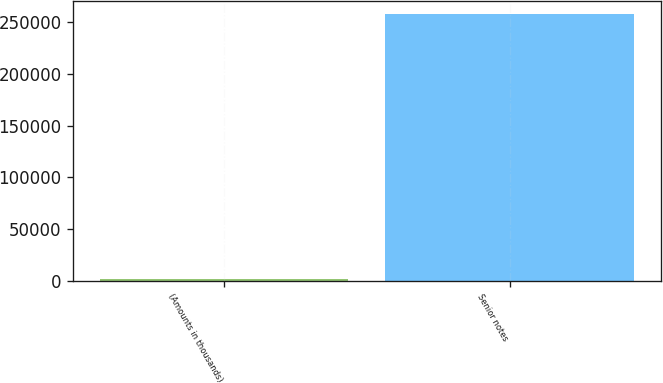<chart> <loc_0><loc_0><loc_500><loc_500><bar_chart><fcel>(Amounts in thousands)<fcel>Senior notes<nl><fcel>2013<fcel>257615<nl></chart> 